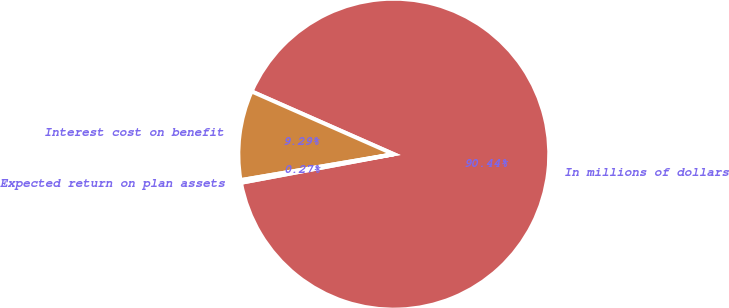Convert chart to OTSL. <chart><loc_0><loc_0><loc_500><loc_500><pie_chart><fcel>In millions of dollars<fcel>Interest cost on benefit<fcel>Expected return on plan assets<nl><fcel>90.44%<fcel>9.29%<fcel>0.27%<nl></chart> 